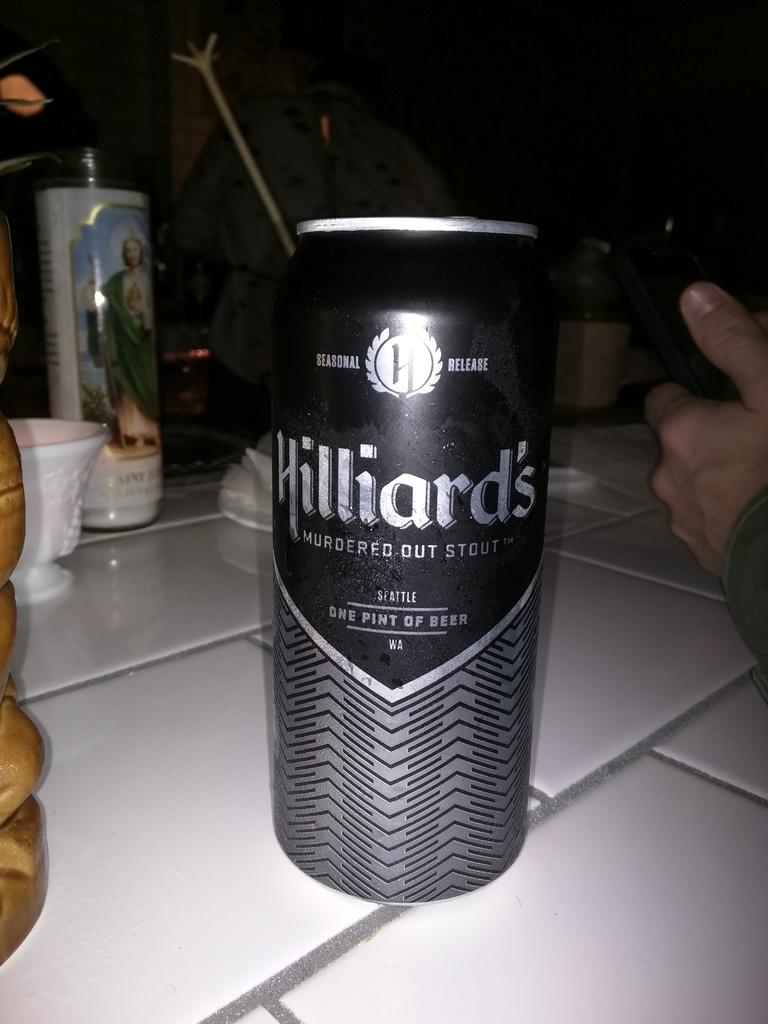<image>
Summarize the visual content of the image. A black and silver can that says Hillard's Murdered Out Stout on the front. 